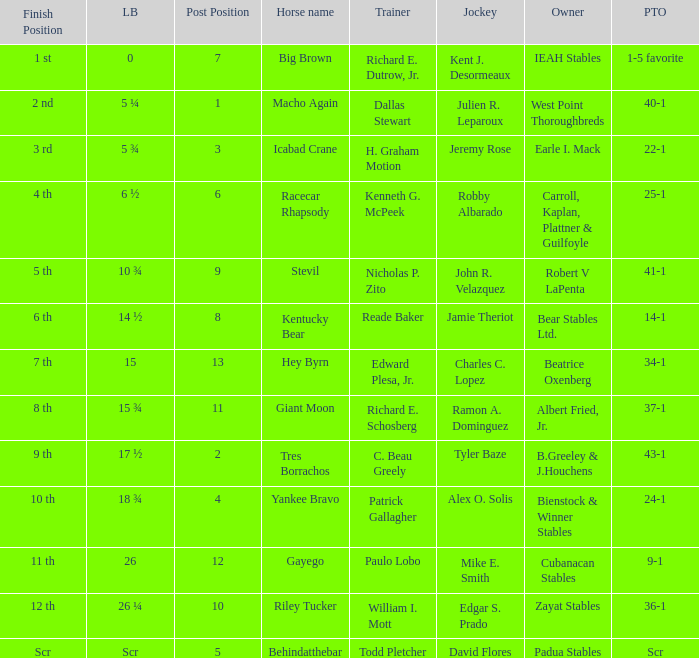Who was the jockey that had post time odds of 34-1? Charles C. Lopez. 